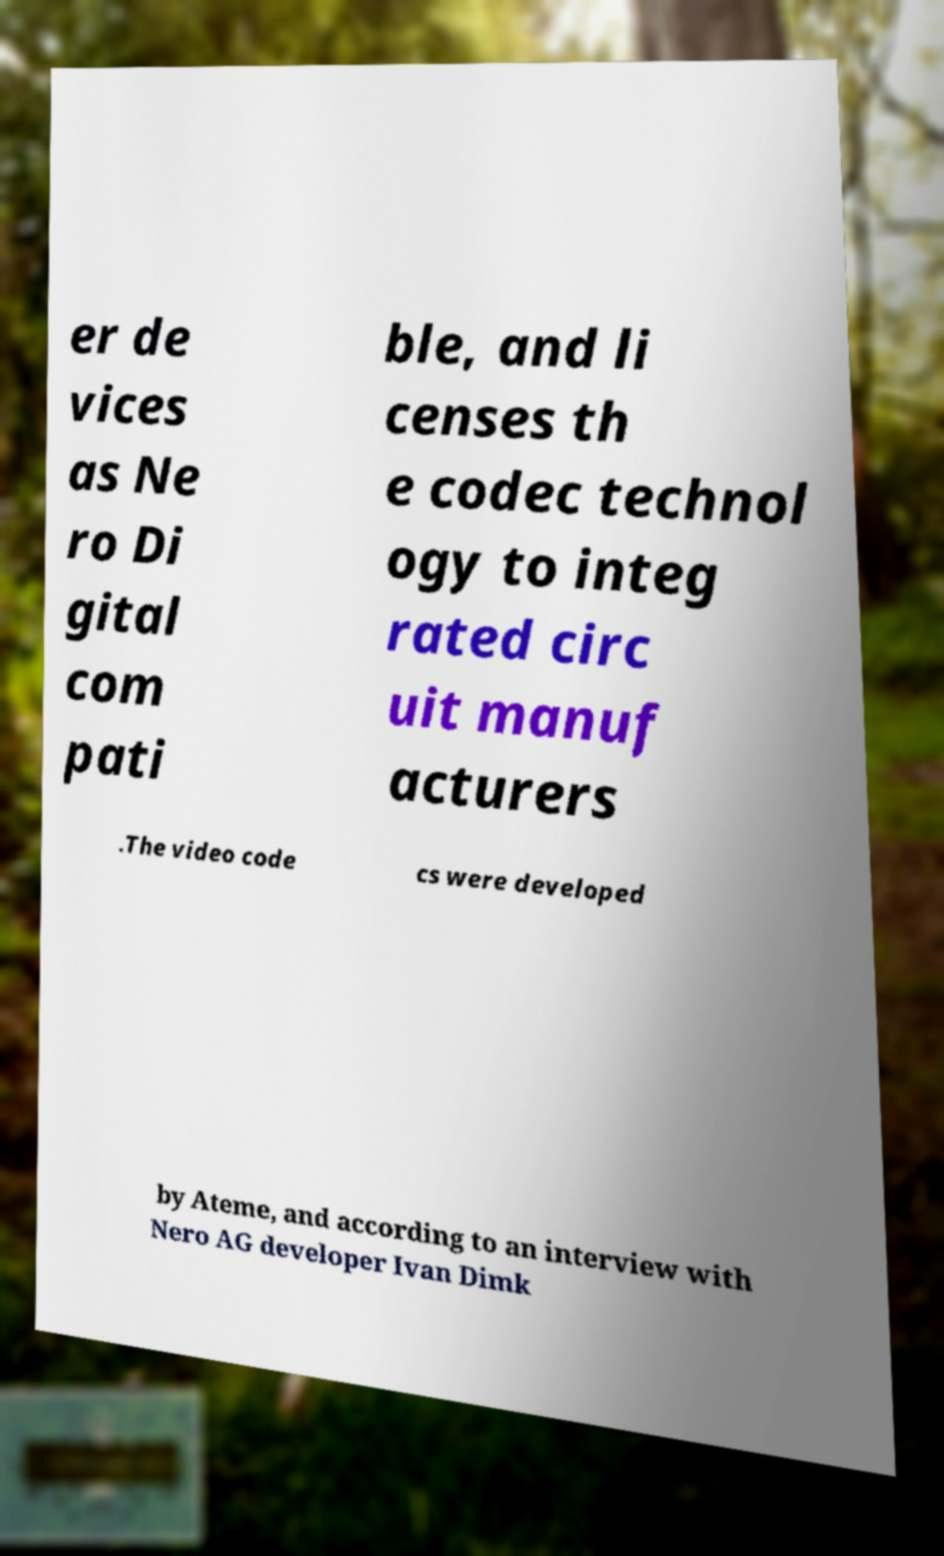What messages or text are displayed in this image? I need them in a readable, typed format. er de vices as Ne ro Di gital com pati ble, and li censes th e codec technol ogy to integ rated circ uit manuf acturers .The video code cs were developed by Ateme, and according to an interview with Nero AG developer Ivan Dimk 